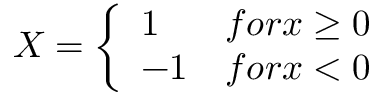<formula> <loc_0><loc_0><loc_500><loc_500>X = \left \{ \begin{array} { l l } { 1 } & { f o r x \geq 0 } \\ { - 1 } & { f o r x < 0 } \end{array}</formula> 